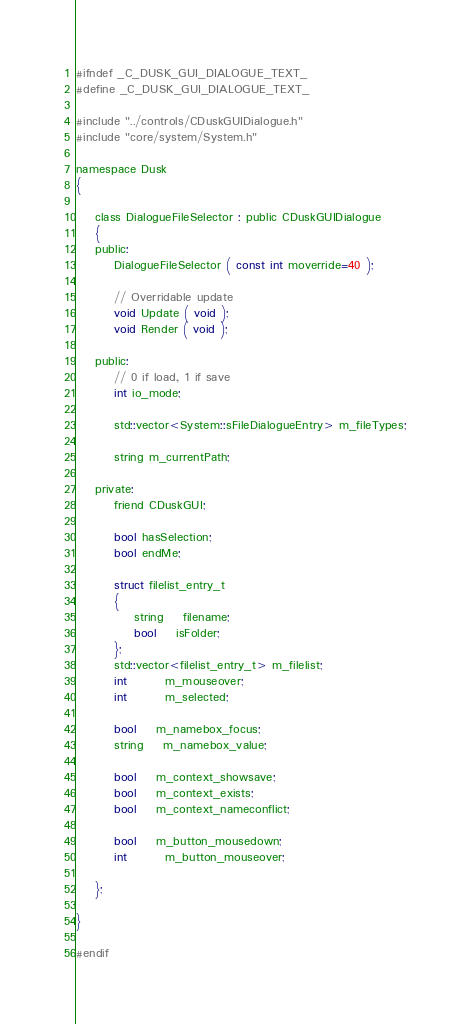Convert code to text. <code><loc_0><loc_0><loc_500><loc_500><_C_>
#ifndef _C_DUSK_GUI_DIALOGUE_TEXT_
#define _C_DUSK_GUI_DIALOGUE_TEXT_

#include "../controls/CDuskGUIDialogue.h"
#include "core/system/System.h"

namespace Dusk
{

	class DialogueFileSelector : public CDuskGUIDialogue
	{
	public:
		DialogueFileSelector ( const int moverride=40 );

		// Overridable update
		void Update ( void );
		void Render ( void );

	public:
		// 0 if load, 1 if save
		int io_mode;

		std::vector<System::sFileDialogueEntry> m_fileTypes;

		string m_currentPath;

	private:
		friend CDuskGUI;

		bool hasSelection;
		bool endMe;

		struct filelist_entry_t
		{
			string	filename;
			bool	isFolder;
		};
		std::vector<filelist_entry_t> m_filelist;
		int		m_mouseover;
		int		m_selected;

		bool	m_namebox_focus;
		string	m_namebox_value;

		bool	m_context_showsave;
		bool	m_context_exists;
		bool	m_context_nameconflict;

		bool	m_button_mousedown;
		int		m_button_mouseover;

	};

}

#endif</code> 